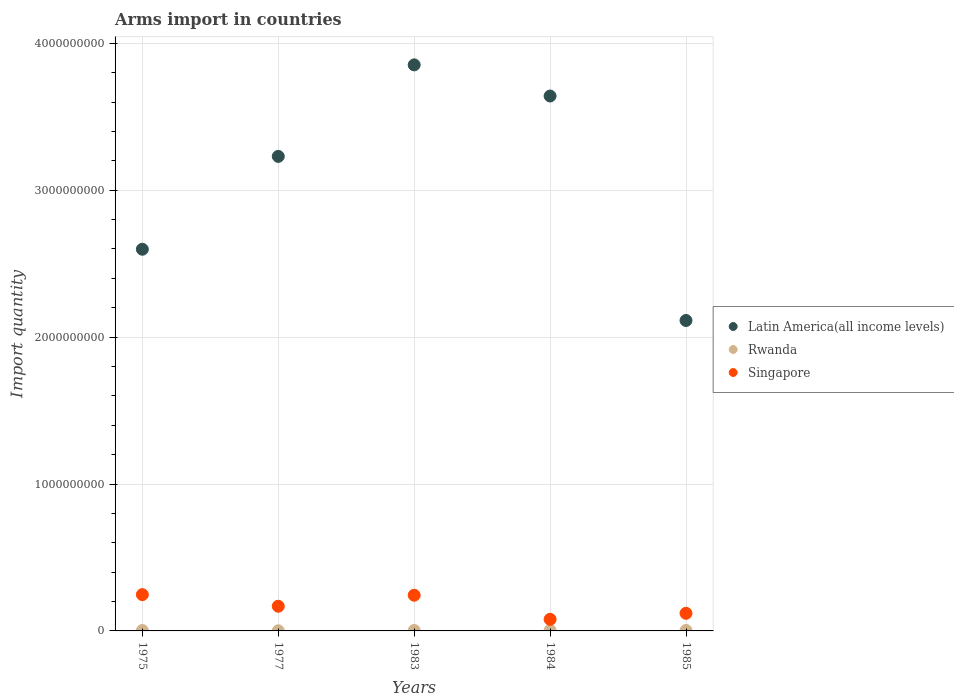What is the total arms import in Latin America(all income levels) in 1984?
Ensure brevity in your answer.  3.64e+09. Across all years, what is the maximum total arms import in Singapore?
Offer a very short reply. 2.47e+08. Across all years, what is the minimum total arms import in Latin America(all income levels)?
Ensure brevity in your answer.  2.11e+09. In which year was the total arms import in Latin America(all income levels) maximum?
Provide a succinct answer. 1983. In which year was the total arms import in Rwanda minimum?
Your answer should be compact. 1977. What is the total total arms import in Rwanda in the graph?
Give a very brief answer. 1.30e+07. What is the difference between the total arms import in Latin America(all income levels) in 1977 and that in 1983?
Offer a very short reply. -6.23e+08. What is the difference between the total arms import in Rwanda in 1985 and the total arms import in Singapore in 1975?
Give a very brief answer. -2.44e+08. What is the average total arms import in Rwanda per year?
Your answer should be very brief. 2.60e+06. In the year 1985, what is the difference between the total arms import in Latin America(all income levels) and total arms import in Singapore?
Offer a terse response. 1.99e+09. Is the total arms import in Rwanda in 1977 less than that in 1984?
Your response must be concise. Yes. What is the difference between the highest and the second highest total arms import in Rwanda?
Keep it short and to the point. 0. What is the difference between the highest and the lowest total arms import in Singapore?
Your answer should be compact. 1.68e+08. In how many years, is the total arms import in Singapore greater than the average total arms import in Singapore taken over all years?
Your answer should be compact. 2. Is the total arms import in Singapore strictly less than the total arms import in Latin America(all income levels) over the years?
Keep it short and to the point. Yes. How many years are there in the graph?
Your answer should be compact. 5. Are the values on the major ticks of Y-axis written in scientific E-notation?
Your answer should be very brief. No. Does the graph contain any zero values?
Your response must be concise. No. Does the graph contain grids?
Keep it short and to the point. Yes. Where does the legend appear in the graph?
Your answer should be very brief. Center right. How many legend labels are there?
Your answer should be very brief. 3. What is the title of the graph?
Keep it short and to the point. Arms import in countries. Does "Guinea" appear as one of the legend labels in the graph?
Keep it short and to the point. No. What is the label or title of the X-axis?
Provide a short and direct response. Years. What is the label or title of the Y-axis?
Keep it short and to the point. Import quantity. What is the Import quantity of Latin America(all income levels) in 1975?
Ensure brevity in your answer.  2.60e+09. What is the Import quantity in Rwanda in 1975?
Your response must be concise. 3.00e+06. What is the Import quantity in Singapore in 1975?
Make the answer very short. 2.47e+08. What is the Import quantity of Latin America(all income levels) in 1977?
Your answer should be compact. 3.23e+09. What is the Import quantity of Singapore in 1977?
Provide a short and direct response. 1.68e+08. What is the Import quantity in Latin America(all income levels) in 1983?
Provide a succinct answer. 3.85e+09. What is the Import quantity in Rwanda in 1983?
Your answer should be compact. 3.00e+06. What is the Import quantity in Singapore in 1983?
Your response must be concise. 2.43e+08. What is the Import quantity of Latin America(all income levels) in 1984?
Your answer should be compact. 3.64e+09. What is the Import quantity of Singapore in 1984?
Your response must be concise. 7.90e+07. What is the Import quantity of Latin America(all income levels) in 1985?
Give a very brief answer. 2.11e+09. What is the Import quantity of Rwanda in 1985?
Keep it short and to the point. 3.00e+06. What is the Import quantity of Singapore in 1985?
Your answer should be very brief. 1.20e+08. Across all years, what is the maximum Import quantity of Latin America(all income levels)?
Your response must be concise. 3.85e+09. Across all years, what is the maximum Import quantity in Singapore?
Make the answer very short. 2.47e+08. Across all years, what is the minimum Import quantity in Latin America(all income levels)?
Keep it short and to the point. 2.11e+09. Across all years, what is the minimum Import quantity in Singapore?
Ensure brevity in your answer.  7.90e+07. What is the total Import quantity of Latin America(all income levels) in the graph?
Provide a succinct answer. 1.54e+1. What is the total Import quantity of Rwanda in the graph?
Keep it short and to the point. 1.30e+07. What is the total Import quantity in Singapore in the graph?
Keep it short and to the point. 8.57e+08. What is the difference between the Import quantity in Latin America(all income levels) in 1975 and that in 1977?
Keep it short and to the point. -6.32e+08. What is the difference between the Import quantity in Rwanda in 1975 and that in 1977?
Your answer should be very brief. 2.00e+06. What is the difference between the Import quantity in Singapore in 1975 and that in 1977?
Offer a very short reply. 7.90e+07. What is the difference between the Import quantity in Latin America(all income levels) in 1975 and that in 1983?
Your response must be concise. -1.26e+09. What is the difference between the Import quantity of Latin America(all income levels) in 1975 and that in 1984?
Your answer should be compact. -1.04e+09. What is the difference between the Import quantity in Rwanda in 1975 and that in 1984?
Your response must be concise. 0. What is the difference between the Import quantity in Singapore in 1975 and that in 1984?
Provide a succinct answer. 1.68e+08. What is the difference between the Import quantity in Latin America(all income levels) in 1975 and that in 1985?
Keep it short and to the point. 4.85e+08. What is the difference between the Import quantity in Rwanda in 1975 and that in 1985?
Your response must be concise. 0. What is the difference between the Import quantity in Singapore in 1975 and that in 1985?
Provide a short and direct response. 1.27e+08. What is the difference between the Import quantity of Latin America(all income levels) in 1977 and that in 1983?
Make the answer very short. -6.23e+08. What is the difference between the Import quantity of Singapore in 1977 and that in 1983?
Ensure brevity in your answer.  -7.50e+07. What is the difference between the Import quantity in Latin America(all income levels) in 1977 and that in 1984?
Your response must be concise. -4.11e+08. What is the difference between the Import quantity in Rwanda in 1977 and that in 1984?
Your response must be concise. -2.00e+06. What is the difference between the Import quantity in Singapore in 1977 and that in 1984?
Keep it short and to the point. 8.90e+07. What is the difference between the Import quantity in Latin America(all income levels) in 1977 and that in 1985?
Your answer should be compact. 1.12e+09. What is the difference between the Import quantity of Singapore in 1977 and that in 1985?
Ensure brevity in your answer.  4.80e+07. What is the difference between the Import quantity in Latin America(all income levels) in 1983 and that in 1984?
Provide a succinct answer. 2.12e+08. What is the difference between the Import quantity of Rwanda in 1983 and that in 1984?
Give a very brief answer. 0. What is the difference between the Import quantity of Singapore in 1983 and that in 1984?
Your answer should be compact. 1.64e+08. What is the difference between the Import quantity in Latin America(all income levels) in 1983 and that in 1985?
Provide a short and direct response. 1.74e+09. What is the difference between the Import quantity in Singapore in 1983 and that in 1985?
Ensure brevity in your answer.  1.23e+08. What is the difference between the Import quantity of Latin America(all income levels) in 1984 and that in 1985?
Your answer should be compact. 1.53e+09. What is the difference between the Import quantity of Singapore in 1984 and that in 1985?
Offer a very short reply. -4.10e+07. What is the difference between the Import quantity in Latin America(all income levels) in 1975 and the Import quantity in Rwanda in 1977?
Your answer should be very brief. 2.60e+09. What is the difference between the Import quantity of Latin America(all income levels) in 1975 and the Import quantity of Singapore in 1977?
Your answer should be compact. 2.43e+09. What is the difference between the Import quantity of Rwanda in 1975 and the Import quantity of Singapore in 1977?
Provide a short and direct response. -1.65e+08. What is the difference between the Import quantity of Latin America(all income levels) in 1975 and the Import quantity of Rwanda in 1983?
Make the answer very short. 2.60e+09. What is the difference between the Import quantity in Latin America(all income levels) in 1975 and the Import quantity in Singapore in 1983?
Provide a succinct answer. 2.36e+09. What is the difference between the Import quantity in Rwanda in 1975 and the Import quantity in Singapore in 1983?
Offer a terse response. -2.40e+08. What is the difference between the Import quantity in Latin America(all income levels) in 1975 and the Import quantity in Rwanda in 1984?
Your answer should be compact. 2.60e+09. What is the difference between the Import quantity of Latin America(all income levels) in 1975 and the Import quantity of Singapore in 1984?
Keep it short and to the point. 2.52e+09. What is the difference between the Import quantity of Rwanda in 1975 and the Import quantity of Singapore in 1984?
Your response must be concise. -7.60e+07. What is the difference between the Import quantity in Latin America(all income levels) in 1975 and the Import quantity in Rwanda in 1985?
Your answer should be compact. 2.60e+09. What is the difference between the Import quantity of Latin America(all income levels) in 1975 and the Import quantity of Singapore in 1985?
Your answer should be very brief. 2.48e+09. What is the difference between the Import quantity of Rwanda in 1975 and the Import quantity of Singapore in 1985?
Provide a succinct answer. -1.17e+08. What is the difference between the Import quantity in Latin America(all income levels) in 1977 and the Import quantity in Rwanda in 1983?
Provide a succinct answer. 3.23e+09. What is the difference between the Import quantity in Latin America(all income levels) in 1977 and the Import quantity in Singapore in 1983?
Your response must be concise. 2.99e+09. What is the difference between the Import quantity in Rwanda in 1977 and the Import quantity in Singapore in 1983?
Your answer should be very brief. -2.42e+08. What is the difference between the Import quantity of Latin America(all income levels) in 1977 and the Import quantity of Rwanda in 1984?
Your answer should be very brief. 3.23e+09. What is the difference between the Import quantity in Latin America(all income levels) in 1977 and the Import quantity in Singapore in 1984?
Your response must be concise. 3.15e+09. What is the difference between the Import quantity in Rwanda in 1977 and the Import quantity in Singapore in 1984?
Make the answer very short. -7.80e+07. What is the difference between the Import quantity in Latin America(all income levels) in 1977 and the Import quantity in Rwanda in 1985?
Make the answer very short. 3.23e+09. What is the difference between the Import quantity in Latin America(all income levels) in 1977 and the Import quantity in Singapore in 1985?
Provide a succinct answer. 3.11e+09. What is the difference between the Import quantity in Rwanda in 1977 and the Import quantity in Singapore in 1985?
Give a very brief answer. -1.19e+08. What is the difference between the Import quantity in Latin America(all income levels) in 1983 and the Import quantity in Rwanda in 1984?
Your response must be concise. 3.85e+09. What is the difference between the Import quantity in Latin America(all income levels) in 1983 and the Import quantity in Singapore in 1984?
Your response must be concise. 3.77e+09. What is the difference between the Import quantity of Rwanda in 1983 and the Import quantity of Singapore in 1984?
Keep it short and to the point. -7.60e+07. What is the difference between the Import quantity of Latin America(all income levels) in 1983 and the Import quantity of Rwanda in 1985?
Your answer should be compact. 3.85e+09. What is the difference between the Import quantity in Latin America(all income levels) in 1983 and the Import quantity in Singapore in 1985?
Your response must be concise. 3.73e+09. What is the difference between the Import quantity in Rwanda in 1983 and the Import quantity in Singapore in 1985?
Keep it short and to the point. -1.17e+08. What is the difference between the Import quantity in Latin America(all income levels) in 1984 and the Import quantity in Rwanda in 1985?
Provide a short and direct response. 3.64e+09. What is the difference between the Import quantity in Latin America(all income levels) in 1984 and the Import quantity in Singapore in 1985?
Offer a very short reply. 3.52e+09. What is the difference between the Import quantity in Rwanda in 1984 and the Import quantity in Singapore in 1985?
Ensure brevity in your answer.  -1.17e+08. What is the average Import quantity of Latin America(all income levels) per year?
Ensure brevity in your answer.  3.09e+09. What is the average Import quantity of Rwanda per year?
Provide a succinct answer. 2.60e+06. What is the average Import quantity in Singapore per year?
Provide a succinct answer. 1.71e+08. In the year 1975, what is the difference between the Import quantity in Latin America(all income levels) and Import quantity in Rwanda?
Give a very brief answer. 2.60e+09. In the year 1975, what is the difference between the Import quantity in Latin America(all income levels) and Import quantity in Singapore?
Keep it short and to the point. 2.35e+09. In the year 1975, what is the difference between the Import quantity of Rwanda and Import quantity of Singapore?
Provide a short and direct response. -2.44e+08. In the year 1977, what is the difference between the Import quantity of Latin America(all income levels) and Import quantity of Rwanda?
Offer a terse response. 3.23e+09. In the year 1977, what is the difference between the Import quantity of Latin America(all income levels) and Import quantity of Singapore?
Ensure brevity in your answer.  3.06e+09. In the year 1977, what is the difference between the Import quantity in Rwanda and Import quantity in Singapore?
Your answer should be compact. -1.67e+08. In the year 1983, what is the difference between the Import quantity of Latin America(all income levels) and Import quantity of Rwanda?
Make the answer very short. 3.85e+09. In the year 1983, what is the difference between the Import quantity in Latin America(all income levels) and Import quantity in Singapore?
Offer a terse response. 3.61e+09. In the year 1983, what is the difference between the Import quantity of Rwanda and Import quantity of Singapore?
Keep it short and to the point. -2.40e+08. In the year 1984, what is the difference between the Import quantity in Latin America(all income levels) and Import quantity in Rwanda?
Ensure brevity in your answer.  3.64e+09. In the year 1984, what is the difference between the Import quantity in Latin America(all income levels) and Import quantity in Singapore?
Your answer should be compact. 3.56e+09. In the year 1984, what is the difference between the Import quantity of Rwanda and Import quantity of Singapore?
Keep it short and to the point. -7.60e+07. In the year 1985, what is the difference between the Import quantity in Latin America(all income levels) and Import quantity in Rwanda?
Offer a very short reply. 2.11e+09. In the year 1985, what is the difference between the Import quantity of Latin America(all income levels) and Import quantity of Singapore?
Give a very brief answer. 1.99e+09. In the year 1985, what is the difference between the Import quantity in Rwanda and Import quantity in Singapore?
Provide a succinct answer. -1.17e+08. What is the ratio of the Import quantity of Latin America(all income levels) in 1975 to that in 1977?
Keep it short and to the point. 0.8. What is the ratio of the Import quantity of Singapore in 1975 to that in 1977?
Your answer should be very brief. 1.47. What is the ratio of the Import quantity of Latin America(all income levels) in 1975 to that in 1983?
Your answer should be very brief. 0.67. What is the ratio of the Import quantity in Singapore in 1975 to that in 1983?
Offer a terse response. 1.02. What is the ratio of the Import quantity in Latin America(all income levels) in 1975 to that in 1984?
Provide a succinct answer. 0.71. What is the ratio of the Import quantity in Singapore in 1975 to that in 1984?
Your answer should be very brief. 3.13. What is the ratio of the Import quantity of Latin America(all income levels) in 1975 to that in 1985?
Your answer should be compact. 1.23. What is the ratio of the Import quantity of Rwanda in 1975 to that in 1985?
Provide a succinct answer. 1. What is the ratio of the Import quantity of Singapore in 1975 to that in 1985?
Make the answer very short. 2.06. What is the ratio of the Import quantity of Latin America(all income levels) in 1977 to that in 1983?
Keep it short and to the point. 0.84. What is the ratio of the Import quantity in Rwanda in 1977 to that in 1983?
Provide a succinct answer. 0.33. What is the ratio of the Import quantity of Singapore in 1977 to that in 1983?
Keep it short and to the point. 0.69. What is the ratio of the Import quantity in Latin America(all income levels) in 1977 to that in 1984?
Give a very brief answer. 0.89. What is the ratio of the Import quantity of Rwanda in 1977 to that in 1984?
Keep it short and to the point. 0.33. What is the ratio of the Import quantity in Singapore in 1977 to that in 1984?
Provide a short and direct response. 2.13. What is the ratio of the Import quantity of Latin America(all income levels) in 1977 to that in 1985?
Give a very brief answer. 1.53. What is the ratio of the Import quantity in Rwanda in 1977 to that in 1985?
Your answer should be very brief. 0.33. What is the ratio of the Import quantity in Latin America(all income levels) in 1983 to that in 1984?
Your answer should be very brief. 1.06. What is the ratio of the Import quantity in Rwanda in 1983 to that in 1984?
Provide a short and direct response. 1. What is the ratio of the Import quantity of Singapore in 1983 to that in 1984?
Make the answer very short. 3.08. What is the ratio of the Import quantity of Latin America(all income levels) in 1983 to that in 1985?
Ensure brevity in your answer.  1.82. What is the ratio of the Import quantity in Rwanda in 1983 to that in 1985?
Make the answer very short. 1. What is the ratio of the Import quantity of Singapore in 1983 to that in 1985?
Offer a terse response. 2.02. What is the ratio of the Import quantity in Latin America(all income levels) in 1984 to that in 1985?
Offer a very short reply. 1.72. What is the ratio of the Import quantity in Rwanda in 1984 to that in 1985?
Provide a short and direct response. 1. What is the ratio of the Import quantity in Singapore in 1984 to that in 1985?
Your answer should be very brief. 0.66. What is the difference between the highest and the second highest Import quantity in Latin America(all income levels)?
Your response must be concise. 2.12e+08. What is the difference between the highest and the second highest Import quantity in Singapore?
Offer a very short reply. 4.00e+06. What is the difference between the highest and the lowest Import quantity in Latin America(all income levels)?
Give a very brief answer. 1.74e+09. What is the difference between the highest and the lowest Import quantity of Singapore?
Your response must be concise. 1.68e+08. 